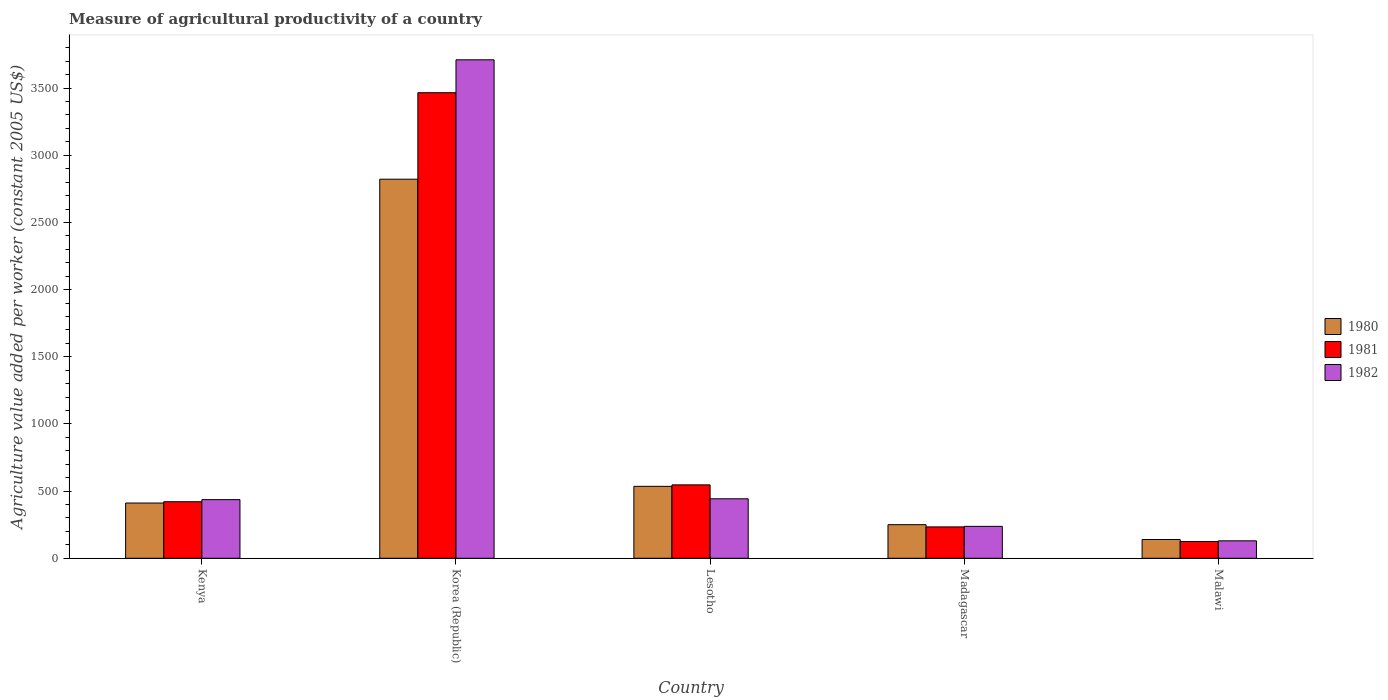How many groups of bars are there?
Offer a very short reply. 5. Are the number of bars per tick equal to the number of legend labels?
Give a very brief answer. Yes. Are the number of bars on each tick of the X-axis equal?
Your answer should be very brief. Yes. How many bars are there on the 3rd tick from the right?
Make the answer very short. 3. What is the label of the 3rd group of bars from the left?
Keep it short and to the point. Lesotho. What is the measure of agricultural productivity in 1980 in Korea (Republic)?
Provide a short and direct response. 2821.97. Across all countries, what is the maximum measure of agricultural productivity in 1981?
Your response must be concise. 3465.84. Across all countries, what is the minimum measure of agricultural productivity in 1982?
Your answer should be compact. 129.9. In which country was the measure of agricultural productivity in 1980 minimum?
Your answer should be very brief. Malawi. What is the total measure of agricultural productivity in 1982 in the graph?
Provide a short and direct response. 4957.68. What is the difference between the measure of agricultural productivity in 1980 in Madagascar and that in Malawi?
Make the answer very short. 110.47. What is the difference between the measure of agricultural productivity in 1980 in Madagascar and the measure of agricultural productivity in 1981 in Malawi?
Offer a very short reply. 125.24. What is the average measure of agricultural productivity in 1981 per country?
Provide a succinct answer. 958.31. What is the difference between the measure of agricultural productivity of/in 1982 and measure of agricultural productivity of/in 1980 in Korea (Republic)?
Make the answer very short. 888.84. What is the ratio of the measure of agricultural productivity in 1982 in Korea (Republic) to that in Madagascar?
Give a very brief answer. 15.61. Is the measure of agricultural productivity in 1980 in Kenya less than that in Korea (Republic)?
Offer a terse response. Yes. What is the difference between the highest and the second highest measure of agricultural productivity in 1981?
Your answer should be very brief. 2919.41. What is the difference between the highest and the lowest measure of agricultural productivity in 1982?
Ensure brevity in your answer.  3580.92. Is the sum of the measure of agricultural productivity in 1982 in Lesotho and Madagascar greater than the maximum measure of agricultural productivity in 1980 across all countries?
Keep it short and to the point. No. What does the 1st bar from the left in Malawi represents?
Ensure brevity in your answer.  1980. Is it the case that in every country, the sum of the measure of agricultural productivity in 1980 and measure of agricultural productivity in 1981 is greater than the measure of agricultural productivity in 1982?
Offer a terse response. Yes. Are all the bars in the graph horizontal?
Keep it short and to the point. No. How many countries are there in the graph?
Give a very brief answer. 5. What is the difference between two consecutive major ticks on the Y-axis?
Provide a succinct answer. 500. Are the values on the major ticks of Y-axis written in scientific E-notation?
Ensure brevity in your answer.  No. Does the graph contain grids?
Your response must be concise. No. Where does the legend appear in the graph?
Your answer should be compact. Center right. How are the legend labels stacked?
Offer a very short reply. Vertical. What is the title of the graph?
Ensure brevity in your answer.  Measure of agricultural productivity of a country. Does "2010" appear as one of the legend labels in the graph?
Ensure brevity in your answer.  No. What is the label or title of the X-axis?
Your answer should be very brief. Country. What is the label or title of the Y-axis?
Provide a succinct answer. Agriculture value added per worker (constant 2005 US$). What is the Agriculture value added per worker (constant 2005 US$) of 1980 in Kenya?
Your response must be concise. 411.31. What is the Agriculture value added per worker (constant 2005 US$) in 1981 in Kenya?
Your answer should be compact. 420.9. What is the Agriculture value added per worker (constant 2005 US$) of 1982 in Kenya?
Provide a short and direct response. 436.56. What is the Agriculture value added per worker (constant 2005 US$) of 1980 in Korea (Republic)?
Make the answer very short. 2821.97. What is the Agriculture value added per worker (constant 2005 US$) of 1981 in Korea (Republic)?
Keep it short and to the point. 3465.84. What is the Agriculture value added per worker (constant 2005 US$) in 1982 in Korea (Republic)?
Make the answer very short. 3710.82. What is the Agriculture value added per worker (constant 2005 US$) in 1980 in Lesotho?
Offer a very short reply. 535.53. What is the Agriculture value added per worker (constant 2005 US$) of 1981 in Lesotho?
Your answer should be compact. 546.43. What is the Agriculture value added per worker (constant 2005 US$) of 1982 in Lesotho?
Your answer should be compact. 442.77. What is the Agriculture value added per worker (constant 2005 US$) in 1980 in Madagascar?
Provide a succinct answer. 250.1. What is the Agriculture value added per worker (constant 2005 US$) in 1981 in Madagascar?
Your answer should be very brief. 233.51. What is the Agriculture value added per worker (constant 2005 US$) in 1982 in Madagascar?
Ensure brevity in your answer.  237.65. What is the Agriculture value added per worker (constant 2005 US$) of 1980 in Malawi?
Offer a terse response. 139.62. What is the Agriculture value added per worker (constant 2005 US$) in 1981 in Malawi?
Ensure brevity in your answer.  124.86. What is the Agriculture value added per worker (constant 2005 US$) in 1982 in Malawi?
Keep it short and to the point. 129.9. Across all countries, what is the maximum Agriculture value added per worker (constant 2005 US$) of 1980?
Ensure brevity in your answer.  2821.97. Across all countries, what is the maximum Agriculture value added per worker (constant 2005 US$) in 1981?
Your answer should be very brief. 3465.84. Across all countries, what is the maximum Agriculture value added per worker (constant 2005 US$) in 1982?
Give a very brief answer. 3710.82. Across all countries, what is the minimum Agriculture value added per worker (constant 2005 US$) in 1980?
Ensure brevity in your answer.  139.62. Across all countries, what is the minimum Agriculture value added per worker (constant 2005 US$) of 1981?
Your response must be concise. 124.86. Across all countries, what is the minimum Agriculture value added per worker (constant 2005 US$) of 1982?
Offer a terse response. 129.9. What is the total Agriculture value added per worker (constant 2005 US$) of 1980 in the graph?
Your response must be concise. 4158.54. What is the total Agriculture value added per worker (constant 2005 US$) of 1981 in the graph?
Give a very brief answer. 4791.55. What is the total Agriculture value added per worker (constant 2005 US$) of 1982 in the graph?
Offer a terse response. 4957.68. What is the difference between the Agriculture value added per worker (constant 2005 US$) in 1980 in Kenya and that in Korea (Republic)?
Give a very brief answer. -2410.66. What is the difference between the Agriculture value added per worker (constant 2005 US$) of 1981 in Kenya and that in Korea (Republic)?
Provide a succinct answer. -3044.95. What is the difference between the Agriculture value added per worker (constant 2005 US$) in 1982 in Kenya and that in Korea (Republic)?
Provide a succinct answer. -3274.26. What is the difference between the Agriculture value added per worker (constant 2005 US$) in 1980 in Kenya and that in Lesotho?
Your answer should be very brief. -124.22. What is the difference between the Agriculture value added per worker (constant 2005 US$) of 1981 in Kenya and that in Lesotho?
Provide a short and direct response. -125.53. What is the difference between the Agriculture value added per worker (constant 2005 US$) of 1982 in Kenya and that in Lesotho?
Make the answer very short. -6.21. What is the difference between the Agriculture value added per worker (constant 2005 US$) of 1980 in Kenya and that in Madagascar?
Offer a terse response. 161.21. What is the difference between the Agriculture value added per worker (constant 2005 US$) in 1981 in Kenya and that in Madagascar?
Ensure brevity in your answer.  187.39. What is the difference between the Agriculture value added per worker (constant 2005 US$) in 1982 in Kenya and that in Madagascar?
Provide a short and direct response. 198.91. What is the difference between the Agriculture value added per worker (constant 2005 US$) of 1980 in Kenya and that in Malawi?
Offer a terse response. 271.69. What is the difference between the Agriculture value added per worker (constant 2005 US$) of 1981 in Kenya and that in Malawi?
Ensure brevity in your answer.  296.04. What is the difference between the Agriculture value added per worker (constant 2005 US$) in 1982 in Kenya and that in Malawi?
Your answer should be very brief. 306.66. What is the difference between the Agriculture value added per worker (constant 2005 US$) in 1980 in Korea (Republic) and that in Lesotho?
Offer a terse response. 2286.45. What is the difference between the Agriculture value added per worker (constant 2005 US$) of 1981 in Korea (Republic) and that in Lesotho?
Give a very brief answer. 2919.41. What is the difference between the Agriculture value added per worker (constant 2005 US$) of 1982 in Korea (Republic) and that in Lesotho?
Offer a terse response. 3268.05. What is the difference between the Agriculture value added per worker (constant 2005 US$) of 1980 in Korea (Republic) and that in Madagascar?
Keep it short and to the point. 2571.88. What is the difference between the Agriculture value added per worker (constant 2005 US$) in 1981 in Korea (Republic) and that in Madagascar?
Provide a succinct answer. 3232.33. What is the difference between the Agriculture value added per worker (constant 2005 US$) of 1982 in Korea (Republic) and that in Madagascar?
Give a very brief answer. 3473.17. What is the difference between the Agriculture value added per worker (constant 2005 US$) in 1980 in Korea (Republic) and that in Malawi?
Offer a terse response. 2682.35. What is the difference between the Agriculture value added per worker (constant 2005 US$) of 1981 in Korea (Republic) and that in Malawi?
Make the answer very short. 3340.98. What is the difference between the Agriculture value added per worker (constant 2005 US$) in 1982 in Korea (Republic) and that in Malawi?
Ensure brevity in your answer.  3580.92. What is the difference between the Agriculture value added per worker (constant 2005 US$) in 1980 in Lesotho and that in Madagascar?
Provide a short and direct response. 285.43. What is the difference between the Agriculture value added per worker (constant 2005 US$) in 1981 in Lesotho and that in Madagascar?
Keep it short and to the point. 312.92. What is the difference between the Agriculture value added per worker (constant 2005 US$) of 1982 in Lesotho and that in Madagascar?
Your answer should be compact. 205.12. What is the difference between the Agriculture value added per worker (constant 2005 US$) of 1980 in Lesotho and that in Malawi?
Your answer should be very brief. 395.9. What is the difference between the Agriculture value added per worker (constant 2005 US$) of 1981 in Lesotho and that in Malawi?
Make the answer very short. 421.57. What is the difference between the Agriculture value added per worker (constant 2005 US$) in 1982 in Lesotho and that in Malawi?
Your answer should be compact. 312.87. What is the difference between the Agriculture value added per worker (constant 2005 US$) in 1980 in Madagascar and that in Malawi?
Make the answer very short. 110.47. What is the difference between the Agriculture value added per worker (constant 2005 US$) in 1981 in Madagascar and that in Malawi?
Keep it short and to the point. 108.65. What is the difference between the Agriculture value added per worker (constant 2005 US$) of 1982 in Madagascar and that in Malawi?
Give a very brief answer. 107.75. What is the difference between the Agriculture value added per worker (constant 2005 US$) in 1980 in Kenya and the Agriculture value added per worker (constant 2005 US$) in 1981 in Korea (Republic)?
Provide a succinct answer. -3054.53. What is the difference between the Agriculture value added per worker (constant 2005 US$) of 1980 in Kenya and the Agriculture value added per worker (constant 2005 US$) of 1982 in Korea (Republic)?
Ensure brevity in your answer.  -3299.51. What is the difference between the Agriculture value added per worker (constant 2005 US$) of 1981 in Kenya and the Agriculture value added per worker (constant 2005 US$) of 1982 in Korea (Republic)?
Your answer should be very brief. -3289.92. What is the difference between the Agriculture value added per worker (constant 2005 US$) in 1980 in Kenya and the Agriculture value added per worker (constant 2005 US$) in 1981 in Lesotho?
Your answer should be very brief. -135.12. What is the difference between the Agriculture value added per worker (constant 2005 US$) of 1980 in Kenya and the Agriculture value added per worker (constant 2005 US$) of 1982 in Lesotho?
Your answer should be compact. -31.45. What is the difference between the Agriculture value added per worker (constant 2005 US$) in 1981 in Kenya and the Agriculture value added per worker (constant 2005 US$) in 1982 in Lesotho?
Offer a very short reply. -21.87. What is the difference between the Agriculture value added per worker (constant 2005 US$) of 1980 in Kenya and the Agriculture value added per worker (constant 2005 US$) of 1981 in Madagascar?
Keep it short and to the point. 177.8. What is the difference between the Agriculture value added per worker (constant 2005 US$) in 1980 in Kenya and the Agriculture value added per worker (constant 2005 US$) in 1982 in Madagascar?
Ensure brevity in your answer.  173.67. What is the difference between the Agriculture value added per worker (constant 2005 US$) in 1981 in Kenya and the Agriculture value added per worker (constant 2005 US$) in 1982 in Madagascar?
Your response must be concise. 183.25. What is the difference between the Agriculture value added per worker (constant 2005 US$) of 1980 in Kenya and the Agriculture value added per worker (constant 2005 US$) of 1981 in Malawi?
Ensure brevity in your answer.  286.45. What is the difference between the Agriculture value added per worker (constant 2005 US$) in 1980 in Kenya and the Agriculture value added per worker (constant 2005 US$) in 1982 in Malawi?
Make the answer very short. 281.41. What is the difference between the Agriculture value added per worker (constant 2005 US$) of 1981 in Kenya and the Agriculture value added per worker (constant 2005 US$) of 1982 in Malawi?
Provide a succinct answer. 291. What is the difference between the Agriculture value added per worker (constant 2005 US$) in 1980 in Korea (Republic) and the Agriculture value added per worker (constant 2005 US$) in 1981 in Lesotho?
Ensure brevity in your answer.  2275.55. What is the difference between the Agriculture value added per worker (constant 2005 US$) in 1980 in Korea (Republic) and the Agriculture value added per worker (constant 2005 US$) in 1982 in Lesotho?
Offer a very short reply. 2379.21. What is the difference between the Agriculture value added per worker (constant 2005 US$) in 1981 in Korea (Republic) and the Agriculture value added per worker (constant 2005 US$) in 1982 in Lesotho?
Keep it short and to the point. 3023.08. What is the difference between the Agriculture value added per worker (constant 2005 US$) in 1980 in Korea (Republic) and the Agriculture value added per worker (constant 2005 US$) in 1981 in Madagascar?
Make the answer very short. 2588.46. What is the difference between the Agriculture value added per worker (constant 2005 US$) in 1980 in Korea (Republic) and the Agriculture value added per worker (constant 2005 US$) in 1982 in Madagascar?
Keep it short and to the point. 2584.33. What is the difference between the Agriculture value added per worker (constant 2005 US$) in 1981 in Korea (Republic) and the Agriculture value added per worker (constant 2005 US$) in 1982 in Madagascar?
Your answer should be very brief. 3228.2. What is the difference between the Agriculture value added per worker (constant 2005 US$) of 1980 in Korea (Republic) and the Agriculture value added per worker (constant 2005 US$) of 1981 in Malawi?
Make the answer very short. 2697.11. What is the difference between the Agriculture value added per worker (constant 2005 US$) of 1980 in Korea (Republic) and the Agriculture value added per worker (constant 2005 US$) of 1982 in Malawi?
Make the answer very short. 2692.08. What is the difference between the Agriculture value added per worker (constant 2005 US$) of 1981 in Korea (Republic) and the Agriculture value added per worker (constant 2005 US$) of 1982 in Malawi?
Provide a succinct answer. 3335.95. What is the difference between the Agriculture value added per worker (constant 2005 US$) in 1980 in Lesotho and the Agriculture value added per worker (constant 2005 US$) in 1981 in Madagascar?
Your answer should be very brief. 302.02. What is the difference between the Agriculture value added per worker (constant 2005 US$) of 1980 in Lesotho and the Agriculture value added per worker (constant 2005 US$) of 1982 in Madagascar?
Keep it short and to the point. 297.88. What is the difference between the Agriculture value added per worker (constant 2005 US$) of 1981 in Lesotho and the Agriculture value added per worker (constant 2005 US$) of 1982 in Madagascar?
Give a very brief answer. 308.78. What is the difference between the Agriculture value added per worker (constant 2005 US$) in 1980 in Lesotho and the Agriculture value added per worker (constant 2005 US$) in 1981 in Malawi?
Ensure brevity in your answer.  410.66. What is the difference between the Agriculture value added per worker (constant 2005 US$) of 1980 in Lesotho and the Agriculture value added per worker (constant 2005 US$) of 1982 in Malawi?
Provide a succinct answer. 405.63. What is the difference between the Agriculture value added per worker (constant 2005 US$) of 1981 in Lesotho and the Agriculture value added per worker (constant 2005 US$) of 1982 in Malawi?
Give a very brief answer. 416.53. What is the difference between the Agriculture value added per worker (constant 2005 US$) in 1980 in Madagascar and the Agriculture value added per worker (constant 2005 US$) in 1981 in Malawi?
Provide a succinct answer. 125.24. What is the difference between the Agriculture value added per worker (constant 2005 US$) in 1980 in Madagascar and the Agriculture value added per worker (constant 2005 US$) in 1982 in Malawi?
Ensure brevity in your answer.  120.2. What is the difference between the Agriculture value added per worker (constant 2005 US$) in 1981 in Madagascar and the Agriculture value added per worker (constant 2005 US$) in 1982 in Malawi?
Keep it short and to the point. 103.61. What is the average Agriculture value added per worker (constant 2005 US$) in 1980 per country?
Provide a short and direct response. 831.71. What is the average Agriculture value added per worker (constant 2005 US$) of 1981 per country?
Offer a very short reply. 958.31. What is the average Agriculture value added per worker (constant 2005 US$) in 1982 per country?
Offer a very short reply. 991.54. What is the difference between the Agriculture value added per worker (constant 2005 US$) in 1980 and Agriculture value added per worker (constant 2005 US$) in 1981 in Kenya?
Ensure brevity in your answer.  -9.59. What is the difference between the Agriculture value added per worker (constant 2005 US$) in 1980 and Agriculture value added per worker (constant 2005 US$) in 1982 in Kenya?
Provide a succinct answer. -25.24. What is the difference between the Agriculture value added per worker (constant 2005 US$) of 1981 and Agriculture value added per worker (constant 2005 US$) of 1982 in Kenya?
Offer a terse response. -15.66. What is the difference between the Agriculture value added per worker (constant 2005 US$) of 1980 and Agriculture value added per worker (constant 2005 US$) of 1981 in Korea (Republic)?
Your answer should be very brief. -643.87. What is the difference between the Agriculture value added per worker (constant 2005 US$) in 1980 and Agriculture value added per worker (constant 2005 US$) in 1982 in Korea (Republic)?
Your response must be concise. -888.84. What is the difference between the Agriculture value added per worker (constant 2005 US$) in 1981 and Agriculture value added per worker (constant 2005 US$) in 1982 in Korea (Republic)?
Ensure brevity in your answer.  -244.97. What is the difference between the Agriculture value added per worker (constant 2005 US$) in 1980 and Agriculture value added per worker (constant 2005 US$) in 1981 in Lesotho?
Provide a short and direct response. -10.9. What is the difference between the Agriculture value added per worker (constant 2005 US$) in 1980 and Agriculture value added per worker (constant 2005 US$) in 1982 in Lesotho?
Give a very brief answer. 92.76. What is the difference between the Agriculture value added per worker (constant 2005 US$) in 1981 and Agriculture value added per worker (constant 2005 US$) in 1982 in Lesotho?
Give a very brief answer. 103.66. What is the difference between the Agriculture value added per worker (constant 2005 US$) of 1980 and Agriculture value added per worker (constant 2005 US$) of 1981 in Madagascar?
Your response must be concise. 16.59. What is the difference between the Agriculture value added per worker (constant 2005 US$) of 1980 and Agriculture value added per worker (constant 2005 US$) of 1982 in Madagascar?
Your answer should be compact. 12.45. What is the difference between the Agriculture value added per worker (constant 2005 US$) in 1981 and Agriculture value added per worker (constant 2005 US$) in 1982 in Madagascar?
Ensure brevity in your answer.  -4.13. What is the difference between the Agriculture value added per worker (constant 2005 US$) in 1980 and Agriculture value added per worker (constant 2005 US$) in 1981 in Malawi?
Keep it short and to the point. 14.76. What is the difference between the Agriculture value added per worker (constant 2005 US$) in 1980 and Agriculture value added per worker (constant 2005 US$) in 1982 in Malawi?
Provide a succinct answer. 9.73. What is the difference between the Agriculture value added per worker (constant 2005 US$) in 1981 and Agriculture value added per worker (constant 2005 US$) in 1982 in Malawi?
Your answer should be compact. -5.03. What is the ratio of the Agriculture value added per worker (constant 2005 US$) in 1980 in Kenya to that in Korea (Republic)?
Your response must be concise. 0.15. What is the ratio of the Agriculture value added per worker (constant 2005 US$) in 1981 in Kenya to that in Korea (Republic)?
Offer a very short reply. 0.12. What is the ratio of the Agriculture value added per worker (constant 2005 US$) in 1982 in Kenya to that in Korea (Republic)?
Your answer should be compact. 0.12. What is the ratio of the Agriculture value added per worker (constant 2005 US$) in 1980 in Kenya to that in Lesotho?
Your answer should be very brief. 0.77. What is the ratio of the Agriculture value added per worker (constant 2005 US$) of 1981 in Kenya to that in Lesotho?
Ensure brevity in your answer.  0.77. What is the ratio of the Agriculture value added per worker (constant 2005 US$) in 1980 in Kenya to that in Madagascar?
Offer a very short reply. 1.64. What is the ratio of the Agriculture value added per worker (constant 2005 US$) of 1981 in Kenya to that in Madagascar?
Keep it short and to the point. 1.8. What is the ratio of the Agriculture value added per worker (constant 2005 US$) in 1982 in Kenya to that in Madagascar?
Offer a terse response. 1.84. What is the ratio of the Agriculture value added per worker (constant 2005 US$) in 1980 in Kenya to that in Malawi?
Your response must be concise. 2.95. What is the ratio of the Agriculture value added per worker (constant 2005 US$) of 1981 in Kenya to that in Malawi?
Ensure brevity in your answer.  3.37. What is the ratio of the Agriculture value added per worker (constant 2005 US$) in 1982 in Kenya to that in Malawi?
Make the answer very short. 3.36. What is the ratio of the Agriculture value added per worker (constant 2005 US$) of 1980 in Korea (Republic) to that in Lesotho?
Your answer should be compact. 5.27. What is the ratio of the Agriculture value added per worker (constant 2005 US$) in 1981 in Korea (Republic) to that in Lesotho?
Make the answer very short. 6.34. What is the ratio of the Agriculture value added per worker (constant 2005 US$) in 1982 in Korea (Republic) to that in Lesotho?
Your response must be concise. 8.38. What is the ratio of the Agriculture value added per worker (constant 2005 US$) in 1980 in Korea (Republic) to that in Madagascar?
Give a very brief answer. 11.28. What is the ratio of the Agriculture value added per worker (constant 2005 US$) in 1981 in Korea (Republic) to that in Madagascar?
Keep it short and to the point. 14.84. What is the ratio of the Agriculture value added per worker (constant 2005 US$) in 1982 in Korea (Republic) to that in Madagascar?
Your answer should be compact. 15.61. What is the ratio of the Agriculture value added per worker (constant 2005 US$) of 1980 in Korea (Republic) to that in Malawi?
Ensure brevity in your answer.  20.21. What is the ratio of the Agriculture value added per worker (constant 2005 US$) in 1981 in Korea (Republic) to that in Malawi?
Make the answer very short. 27.76. What is the ratio of the Agriculture value added per worker (constant 2005 US$) in 1982 in Korea (Republic) to that in Malawi?
Give a very brief answer. 28.57. What is the ratio of the Agriculture value added per worker (constant 2005 US$) in 1980 in Lesotho to that in Madagascar?
Provide a short and direct response. 2.14. What is the ratio of the Agriculture value added per worker (constant 2005 US$) in 1981 in Lesotho to that in Madagascar?
Ensure brevity in your answer.  2.34. What is the ratio of the Agriculture value added per worker (constant 2005 US$) in 1982 in Lesotho to that in Madagascar?
Provide a succinct answer. 1.86. What is the ratio of the Agriculture value added per worker (constant 2005 US$) of 1980 in Lesotho to that in Malawi?
Provide a short and direct response. 3.84. What is the ratio of the Agriculture value added per worker (constant 2005 US$) of 1981 in Lesotho to that in Malawi?
Your answer should be very brief. 4.38. What is the ratio of the Agriculture value added per worker (constant 2005 US$) in 1982 in Lesotho to that in Malawi?
Provide a short and direct response. 3.41. What is the ratio of the Agriculture value added per worker (constant 2005 US$) of 1980 in Madagascar to that in Malawi?
Your response must be concise. 1.79. What is the ratio of the Agriculture value added per worker (constant 2005 US$) of 1981 in Madagascar to that in Malawi?
Ensure brevity in your answer.  1.87. What is the ratio of the Agriculture value added per worker (constant 2005 US$) in 1982 in Madagascar to that in Malawi?
Your answer should be very brief. 1.83. What is the difference between the highest and the second highest Agriculture value added per worker (constant 2005 US$) of 1980?
Your response must be concise. 2286.45. What is the difference between the highest and the second highest Agriculture value added per worker (constant 2005 US$) in 1981?
Make the answer very short. 2919.41. What is the difference between the highest and the second highest Agriculture value added per worker (constant 2005 US$) of 1982?
Provide a short and direct response. 3268.05. What is the difference between the highest and the lowest Agriculture value added per worker (constant 2005 US$) in 1980?
Provide a succinct answer. 2682.35. What is the difference between the highest and the lowest Agriculture value added per worker (constant 2005 US$) of 1981?
Provide a short and direct response. 3340.98. What is the difference between the highest and the lowest Agriculture value added per worker (constant 2005 US$) of 1982?
Offer a terse response. 3580.92. 